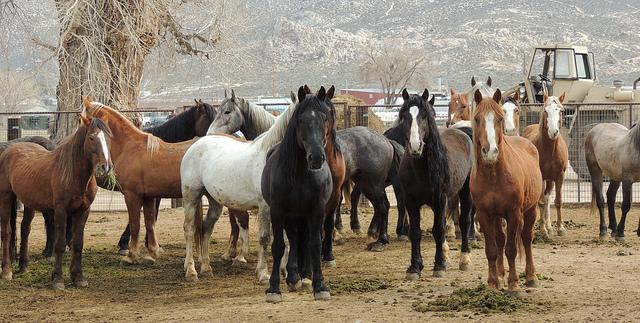What is the name of the fenced off area for these horses?

Choices:
A) corral
B) dirt road
C) parking lot
D) stage corral 